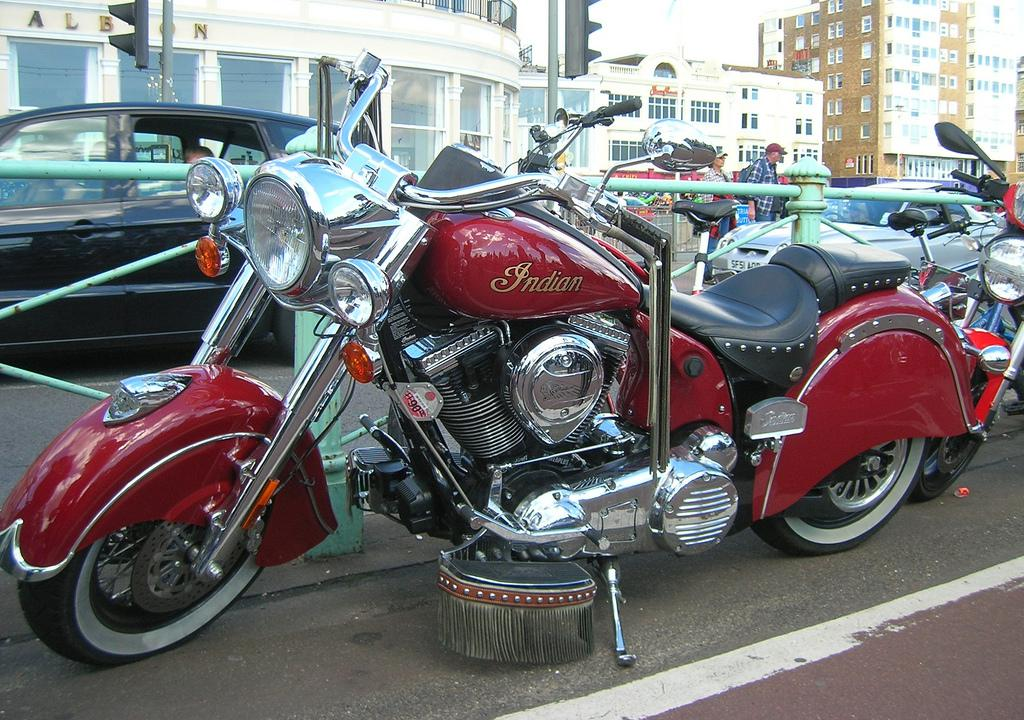Question: how many lights are on the front of the motorcycle?
Choices:
A. Two.
B. One.
C. Three.
D. Four.
Answer with the letter. Answer: C Question: what is the name on the motorcycle?
Choices:
A. Harley.
B. Scout.
C. Demon.
D. Indian.
Answer with the letter. Answer: D Question: how many tires does the motorcycle have?
Choices:
A. One.
B. None.
C. Two.
D. Three.
Answer with the letter. Answer: C Question: what is in the background?
Choices:
A. Buildings.
B. Cars.
C. Trees.
D. Street lights.
Answer with the letter. Answer: A Question: how many buildings are there?
Choices:
A. Four.
B. Five.
C. Three.
D. Six.
Answer with the letter. Answer: C Question: what is in front of a light green railing?
Choices:
A. A car.
B. A truck.
C. A lawnmower.
D. A motorcycle.
Answer with the letter. Answer: D Question: what is in the background?
Choices:
A. A black car.
B. A goose.
C. A red house.
D. A little girl.
Answer with the letter. Answer: A Question: how many cars pass behind the motorcycle?
Choices:
A. Three.
B. Two.
C. Four.
D. Five.
Answer with the letter. Answer: B Question: what brand is the motorcycle?
Choices:
A. Harley.
B. Indian.
C. Suzuki.
D. Honda.
Answer with the letter. Answer: B Question: how many headlights does it have?
Choices:
A. Four.
B. Three.
C. Two.
D. Six.
Answer with the letter. Answer: B Question: how much of the bike wheels are covered?
Choices:
A. Approximately 40%.
B. Approximately 50%.
C. Approximately 60%.
D. Approximately 30%.
Answer with the letter. Answer: B Question: how many people are in the background?
Choices:
A. Four.
B. Six.
C. Two.
D. Eight.
Answer with the letter. Answer: C 